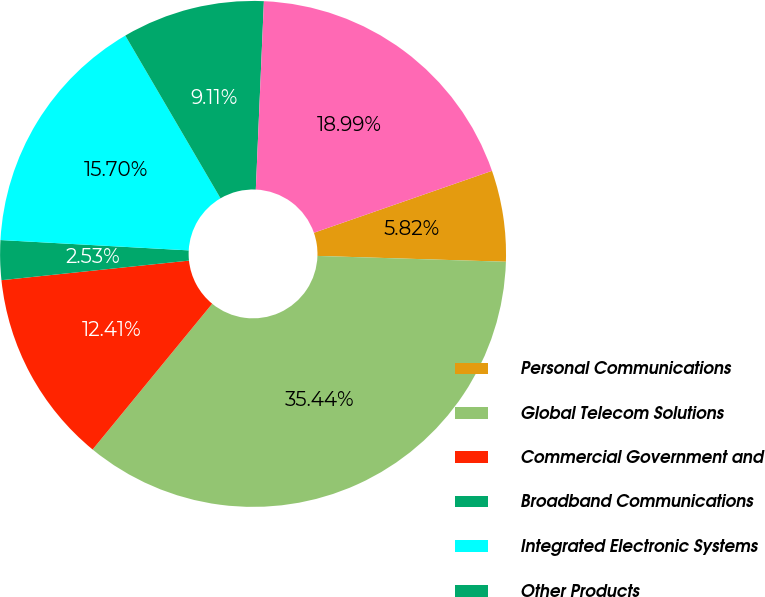<chart> <loc_0><loc_0><loc_500><loc_500><pie_chart><fcel>Personal Communications<fcel>Global Telecom Solutions<fcel>Commercial Government and<fcel>Broadband Communications<fcel>Integrated Electronic Systems<fcel>Other Products<fcel>General Corporate<nl><fcel>5.82%<fcel>35.44%<fcel>12.41%<fcel>2.53%<fcel>15.7%<fcel>9.11%<fcel>18.99%<nl></chart> 